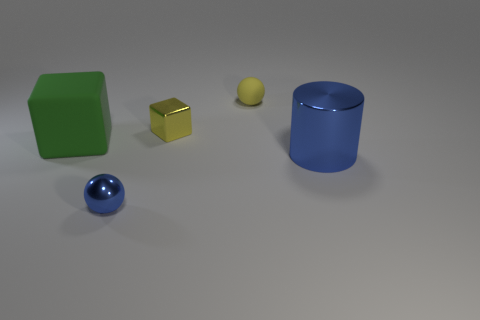Add 2 large cyan objects. How many objects exist? 7 Subtract all cubes. How many objects are left? 3 Add 5 red metal blocks. How many red metal blocks exist? 5 Subtract 0 gray cylinders. How many objects are left? 5 Subtract all green metal cubes. Subtract all metallic cylinders. How many objects are left? 4 Add 3 big cylinders. How many big cylinders are left? 4 